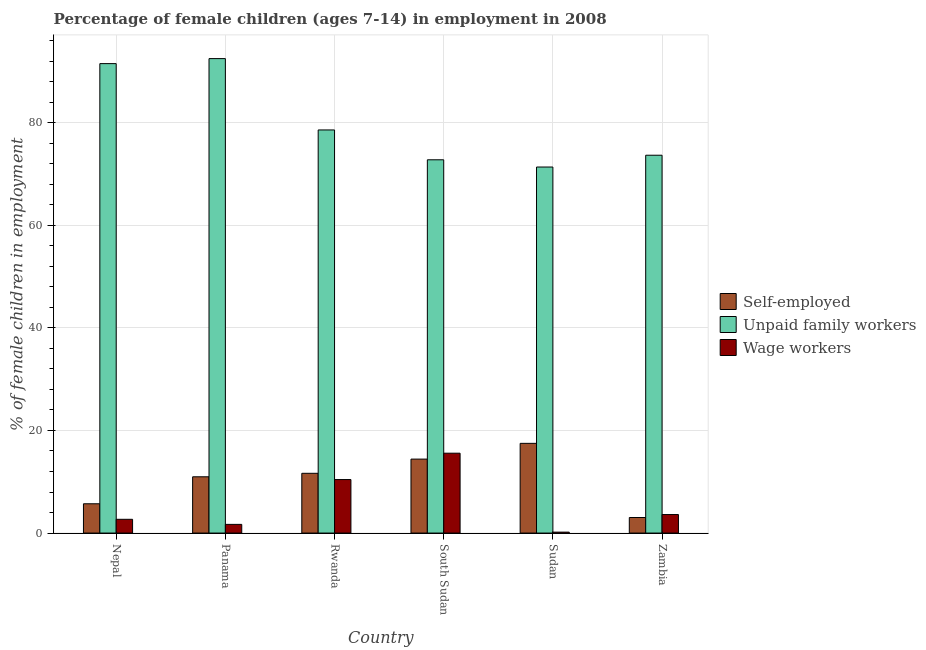How many different coloured bars are there?
Offer a terse response. 3. How many groups of bars are there?
Provide a short and direct response. 6. Are the number of bars per tick equal to the number of legend labels?
Offer a very short reply. Yes. How many bars are there on the 2nd tick from the right?
Give a very brief answer. 3. What is the label of the 3rd group of bars from the left?
Keep it short and to the point. Rwanda. In how many cases, is the number of bars for a given country not equal to the number of legend labels?
Keep it short and to the point. 0. What is the percentage of self employed children in Zambia?
Your answer should be very brief. 3.03. Across all countries, what is the maximum percentage of self employed children?
Offer a very short reply. 17.49. Across all countries, what is the minimum percentage of children employed as wage workers?
Make the answer very short. 0.18. In which country was the percentage of children employed as unpaid family workers maximum?
Provide a succinct answer. Panama. In which country was the percentage of self employed children minimum?
Make the answer very short. Zambia. What is the total percentage of self employed children in the graph?
Give a very brief answer. 63.27. What is the difference between the percentage of self employed children in Nepal and that in Rwanda?
Ensure brevity in your answer.  -5.94. What is the difference between the percentage of children employed as unpaid family workers in Sudan and the percentage of children employed as wage workers in South Sudan?
Keep it short and to the point. 55.8. What is the average percentage of children employed as unpaid family workers per country?
Offer a terse response. 80.08. What is the difference between the percentage of children employed as wage workers and percentage of children employed as unpaid family workers in Nepal?
Your answer should be very brief. -88.85. In how many countries, is the percentage of children employed as wage workers greater than 68 %?
Keep it short and to the point. 0. What is the ratio of the percentage of children employed as wage workers in Nepal to that in Zambia?
Your answer should be compact. 0.74. What is the difference between the highest and the second highest percentage of self employed children?
Your response must be concise. 3.07. What is the difference between the highest and the lowest percentage of children employed as wage workers?
Your answer should be very brief. 15.39. In how many countries, is the percentage of children employed as wage workers greater than the average percentage of children employed as wage workers taken over all countries?
Your answer should be compact. 2. Is the sum of the percentage of children employed as wage workers in South Sudan and Zambia greater than the maximum percentage of children employed as unpaid family workers across all countries?
Make the answer very short. No. What does the 2nd bar from the left in Panama represents?
Keep it short and to the point. Unpaid family workers. What does the 1st bar from the right in Nepal represents?
Your answer should be compact. Wage workers. How many bars are there?
Offer a terse response. 18. What is the difference between two consecutive major ticks on the Y-axis?
Provide a succinct answer. 20. Are the values on the major ticks of Y-axis written in scientific E-notation?
Offer a terse response. No. Does the graph contain any zero values?
Give a very brief answer. No. How many legend labels are there?
Offer a terse response. 3. What is the title of the graph?
Offer a very short reply. Percentage of female children (ages 7-14) in employment in 2008. What is the label or title of the Y-axis?
Your answer should be very brief. % of female children in employment. What is the % of female children in employment in Self-employed in Nepal?
Provide a short and direct response. 5.71. What is the % of female children in employment in Unpaid family workers in Nepal?
Your response must be concise. 91.53. What is the % of female children in employment of Wage workers in Nepal?
Your answer should be very brief. 2.68. What is the % of female children in employment in Self-employed in Panama?
Your answer should be compact. 10.97. What is the % of female children in employment in Unpaid family workers in Panama?
Provide a short and direct response. 92.51. What is the % of female children in employment of Wage workers in Panama?
Provide a short and direct response. 1.69. What is the % of female children in employment in Self-employed in Rwanda?
Provide a succinct answer. 11.65. What is the % of female children in employment in Unpaid family workers in Rwanda?
Keep it short and to the point. 78.6. What is the % of female children in employment in Wage workers in Rwanda?
Offer a very short reply. 10.43. What is the % of female children in employment of Self-employed in South Sudan?
Give a very brief answer. 14.42. What is the % of female children in employment in Unpaid family workers in South Sudan?
Keep it short and to the point. 72.78. What is the % of female children in employment of Wage workers in South Sudan?
Offer a very short reply. 15.57. What is the % of female children in employment in Self-employed in Sudan?
Give a very brief answer. 17.49. What is the % of female children in employment in Unpaid family workers in Sudan?
Your answer should be compact. 71.37. What is the % of female children in employment of Wage workers in Sudan?
Your answer should be very brief. 0.18. What is the % of female children in employment of Self-employed in Zambia?
Offer a very short reply. 3.03. What is the % of female children in employment of Unpaid family workers in Zambia?
Your response must be concise. 73.67. What is the % of female children in employment in Wage workers in Zambia?
Your response must be concise. 3.61. Across all countries, what is the maximum % of female children in employment in Self-employed?
Provide a short and direct response. 17.49. Across all countries, what is the maximum % of female children in employment in Unpaid family workers?
Offer a very short reply. 92.51. Across all countries, what is the maximum % of female children in employment in Wage workers?
Keep it short and to the point. 15.57. Across all countries, what is the minimum % of female children in employment in Self-employed?
Keep it short and to the point. 3.03. Across all countries, what is the minimum % of female children in employment of Unpaid family workers?
Keep it short and to the point. 71.37. Across all countries, what is the minimum % of female children in employment in Wage workers?
Give a very brief answer. 0.18. What is the total % of female children in employment in Self-employed in the graph?
Make the answer very short. 63.27. What is the total % of female children in employment of Unpaid family workers in the graph?
Make the answer very short. 480.46. What is the total % of female children in employment in Wage workers in the graph?
Offer a terse response. 34.16. What is the difference between the % of female children in employment in Self-employed in Nepal and that in Panama?
Provide a succinct answer. -5.26. What is the difference between the % of female children in employment of Unpaid family workers in Nepal and that in Panama?
Your answer should be compact. -0.98. What is the difference between the % of female children in employment of Wage workers in Nepal and that in Panama?
Your response must be concise. 0.99. What is the difference between the % of female children in employment of Self-employed in Nepal and that in Rwanda?
Offer a very short reply. -5.94. What is the difference between the % of female children in employment in Unpaid family workers in Nepal and that in Rwanda?
Provide a short and direct response. 12.93. What is the difference between the % of female children in employment in Wage workers in Nepal and that in Rwanda?
Your response must be concise. -7.75. What is the difference between the % of female children in employment of Self-employed in Nepal and that in South Sudan?
Your response must be concise. -8.71. What is the difference between the % of female children in employment in Unpaid family workers in Nepal and that in South Sudan?
Your answer should be very brief. 18.75. What is the difference between the % of female children in employment in Wage workers in Nepal and that in South Sudan?
Ensure brevity in your answer.  -12.89. What is the difference between the % of female children in employment of Self-employed in Nepal and that in Sudan?
Your response must be concise. -11.78. What is the difference between the % of female children in employment of Unpaid family workers in Nepal and that in Sudan?
Your response must be concise. 20.16. What is the difference between the % of female children in employment in Self-employed in Nepal and that in Zambia?
Your answer should be very brief. 2.68. What is the difference between the % of female children in employment of Unpaid family workers in Nepal and that in Zambia?
Offer a terse response. 17.86. What is the difference between the % of female children in employment in Wage workers in Nepal and that in Zambia?
Offer a very short reply. -0.93. What is the difference between the % of female children in employment of Self-employed in Panama and that in Rwanda?
Provide a short and direct response. -0.68. What is the difference between the % of female children in employment of Unpaid family workers in Panama and that in Rwanda?
Offer a very short reply. 13.91. What is the difference between the % of female children in employment in Wage workers in Panama and that in Rwanda?
Offer a terse response. -8.74. What is the difference between the % of female children in employment of Self-employed in Panama and that in South Sudan?
Keep it short and to the point. -3.45. What is the difference between the % of female children in employment in Unpaid family workers in Panama and that in South Sudan?
Give a very brief answer. 19.73. What is the difference between the % of female children in employment of Wage workers in Panama and that in South Sudan?
Offer a terse response. -13.88. What is the difference between the % of female children in employment of Self-employed in Panama and that in Sudan?
Your answer should be very brief. -6.52. What is the difference between the % of female children in employment in Unpaid family workers in Panama and that in Sudan?
Make the answer very short. 21.14. What is the difference between the % of female children in employment of Wage workers in Panama and that in Sudan?
Provide a short and direct response. 1.51. What is the difference between the % of female children in employment in Self-employed in Panama and that in Zambia?
Offer a terse response. 7.94. What is the difference between the % of female children in employment in Unpaid family workers in Panama and that in Zambia?
Your answer should be compact. 18.84. What is the difference between the % of female children in employment of Wage workers in Panama and that in Zambia?
Provide a short and direct response. -1.92. What is the difference between the % of female children in employment in Self-employed in Rwanda and that in South Sudan?
Your answer should be very brief. -2.77. What is the difference between the % of female children in employment of Unpaid family workers in Rwanda and that in South Sudan?
Your response must be concise. 5.82. What is the difference between the % of female children in employment of Wage workers in Rwanda and that in South Sudan?
Ensure brevity in your answer.  -5.14. What is the difference between the % of female children in employment in Self-employed in Rwanda and that in Sudan?
Keep it short and to the point. -5.84. What is the difference between the % of female children in employment in Unpaid family workers in Rwanda and that in Sudan?
Your answer should be very brief. 7.23. What is the difference between the % of female children in employment in Wage workers in Rwanda and that in Sudan?
Provide a short and direct response. 10.25. What is the difference between the % of female children in employment in Self-employed in Rwanda and that in Zambia?
Your answer should be compact. 8.62. What is the difference between the % of female children in employment in Unpaid family workers in Rwanda and that in Zambia?
Your answer should be compact. 4.93. What is the difference between the % of female children in employment of Wage workers in Rwanda and that in Zambia?
Your answer should be very brief. 6.82. What is the difference between the % of female children in employment of Self-employed in South Sudan and that in Sudan?
Provide a succinct answer. -3.07. What is the difference between the % of female children in employment of Unpaid family workers in South Sudan and that in Sudan?
Provide a succinct answer. 1.41. What is the difference between the % of female children in employment of Wage workers in South Sudan and that in Sudan?
Give a very brief answer. 15.39. What is the difference between the % of female children in employment of Self-employed in South Sudan and that in Zambia?
Provide a succinct answer. 11.39. What is the difference between the % of female children in employment in Unpaid family workers in South Sudan and that in Zambia?
Your response must be concise. -0.89. What is the difference between the % of female children in employment in Wage workers in South Sudan and that in Zambia?
Your answer should be compact. 11.96. What is the difference between the % of female children in employment in Self-employed in Sudan and that in Zambia?
Your answer should be very brief. 14.46. What is the difference between the % of female children in employment of Unpaid family workers in Sudan and that in Zambia?
Provide a short and direct response. -2.3. What is the difference between the % of female children in employment of Wage workers in Sudan and that in Zambia?
Your answer should be compact. -3.43. What is the difference between the % of female children in employment of Self-employed in Nepal and the % of female children in employment of Unpaid family workers in Panama?
Provide a succinct answer. -86.8. What is the difference between the % of female children in employment in Self-employed in Nepal and the % of female children in employment in Wage workers in Panama?
Offer a terse response. 4.02. What is the difference between the % of female children in employment of Unpaid family workers in Nepal and the % of female children in employment of Wage workers in Panama?
Keep it short and to the point. 89.84. What is the difference between the % of female children in employment of Self-employed in Nepal and the % of female children in employment of Unpaid family workers in Rwanda?
Provide a short and direct response. -72.89. What is the difference between the % of female children in employment in Self-employed in Nepal and the % of female children in employment in Wage workers in Rwanda?
Provide a short and direct response. -4.72. What is the difference between the % of female children in employment of Unpaid family workers in Nepal and the % of female children in employment of Wage workers in Rwanda?
Keep it short and to the point. 81.1. What is the difference between the % of female children in employment in Self-employed in Nepal and the % of female children in employment in Unpaid family workers in South Sudan?
Your answer should be compact. -67.07. What is the difference between the % of female children in employment of Self-employed in Nepal and the % of female children in employment of Wage workers in South Sudan?
Make the answer very short. -9.86. What is the difference between the % of female children in employment in Unpaid family workers in Nepal and the % of female children in employment in Wage workers in South Sudan?
Your answer should be compact. 75.96. What is the difference between the % of female children in employment of Self-employed in Nepal and the % of female children in employment of Unpaid family workers in Sudan?
Provide a succinct answer. -65.66. What is the difference between the % of female children in employment of Self-employed in Nepal and the % of female children in employment of Wage workers in Sudan?
Ensure brevity in your answer.  5.53. What is the difference between the % of female children in employment of Unpaid family workers in Nepal and the % of female children in employment of Wage workers in Sudan?
Offer a terse response. 91.35. What is the difference between the % of female children in employment in Self-employed in Nepal and the % of female children in employment in Unpaid family workers in Zambia?
Your response must be concise. -67.96. What is the difference between the % of female children in employment in Unpaid family workers in Nepal and the % of female children in employment in Wage workers in Zambia?
Provide a succinct answer. 87.92. What is the difference between the % of female children in employment in Self-employed in Panama and the % of female children in employment in Unpaid family workers in Rwanda?
Your answer should be compact. -67.63. What is the difference between the % of female children in employment in Self-employed in Panama and the % of female children in employment in Wage workers in Rwanda?
Make the answer very short. 0.54. What is the difference between the % of female children in employment in Unpaid family workers in Panama and the % of female children in employment in Wage workers in Rwanda?
Make the answer very short. 82.08. What is the difference between the % of female children in employment of Self-employed in Panama and the % of female children in employment of Unpaid family workers in South Sudan?
Provide a short and direct response. -61.81. What is the difference between the % of female children in employment in Unpaid family workers in Panama and the % of female children in employment in Wage workers in South Sudan?
Your answer should be compact. 76.94. What is the difference between the % of female children in employment in Self-employed in Panama and the % of female children in employment in Unpaid family workers in Sudan?
Your response must be concise. -60.4. What is the difference between the % of female children in employment in Self-employed in Panama and the % of female children in employment in Wage workers in Sudan?
Ensure brevity in your answer.  10.79. What is the difference between the % of female children in employment in Unpaid family workers in Panama and the % of female children in employment in Wage workers in Sudan?
Give a very brief answer. 92.33. What is the difference between the % of female children in employment in Self-employed in Panama and the % of female children in employment in Unpaid family workers in Zambia?
Your response must be concise. -62.7. What is the difference between the % of female children in employment of Self-employed in Panama and the % of female children in employment of Wage workers in Zambia?
Give a very brief answer. 7.36. What is the difference between the % of female children in employment of Unpaid family workers in Panama and the % of female children in employment of Wage workers in Zambia?
Provide a succinct answer. 88.9. What is the difference between the % of female children in employment in Self-employed in Rwanda and the % of female children in employment in Unpaid family workers in South Sudan?
Your response must be concise. -61.13. What is the difference between the % of female children in employment in Self-employed in Rwanda and the % of female children in employment in Wage workers in South Sudan?
Keep it short and to the point. -3.92. What is the difference between the % of female children in employment in Unpaid family workers in Rwanda and the % of female children in employment in Wage workers in South Sudan?
Provide a short and direct response. 63.03. What is the difference between the % of female children in employment in Self-employed in Rwanda and the % of female children in employment in Unpaid family workers in Sudan?
Offer a very short reply. -59.72. What is the difference between the % of female children in employment of Self-employed in Rwanda and the % of female children in employment of Wage workers in Sudan?
Give a very brief answer. 11.47. What is the difference between the % of female children in employment in Unpaid family workers in Rwanda and the % of female children in employment in Wage workers in Sudan?
Keep it short and to the point. 78.42. What is the difference between the % of female children in employment in Self-employed in Rwanda and the % of female children in employment in Unpaid family workers in Zambia?
Provide a short and direct response. -62.02. What is the difference between the % of female children in employment in Self-employed in Rwanda and the % of female children in employment in Wage workers in Zambia?
Your answer should be compact. 8.04. What is the difference between the % of female children in employment in Unpaid family workers in Rwanda and the % of female children in employment in Wage workers in Zambia?
Make the answer very short. 74.99. What is the difference between the % of female children in employment of Self-employed in South Sudan and the % of female children in employment of Unpaid family workers in Sudan?
Provide a short and direct response. -56.95. What is the difference between the % of female children in employment in Self-employed in South Sudan and the % of female children in employment in Wage workers in Sudan?
Your response must be concise. 14.24. What is the difference between the % of female children in employment in Unpaid family workers in South Sudan and the % of female children in employment in Wage workers in Sudan?
Your answer should be compact. 72.6. What is the difference between the % of female children in employment of Self-employed in South Sudan and the % of female children in employment of Unpaid family workers in Zambia?
Keep it short and to the point. -59.25. What is the difference between the % of female children in employment in Self-employed in South Sudan and the % of female children in employment in Wage workers in Zambia?
Provide a short and direct response. 10.81. What is the difference between the % of female children in employment in Unpaid family workers in South Sudan and the % of female children in employment in Wage workers in Zambia?
Your response must be concise. 69.17. What is the difference between the % of female children in employment in Self-employed in Sudan and the % of female children in employment in Unpaid family workers in Zambia?
Offer a terse response. -56.18. What is the difference between the % of female children in employment of Self-employed in Sudan and the % of female children in employment of Wage workers in Zambia?
Keep it short and to the point. 13.88. What is the difference between the % of female children in employment of Unpaid family workers in Sudan and the % of female children in employment of Wage workers in Zambia?
Provide a succinct answer. 67.76. What is the average % of female children in employment of Self-employed per country?
Offer a terse response. 10.54. What is the average % of female children in employment in Unpaid family workers per country?
Keep it short and to the point. 80.08. What is the average % of female children in employment of Wage workers per country?
Offer a terse response. 5.69. What is the difference between the % of female children in employment of Self-employed and % of female children in employment of Unpaid family workers in Nepal?
Your answer should be very brief. -85.82. What is the difference between the % of female children in employment in Self-employed and % of female children in employment in Wage workers in Nepal?
Provide a succinct answer. 3.03. What is the difference between the % of female children in employment of Unpaid family workers and % of female children in employment of Wage workers in Nepal?
Provide a succinct answer. 88.85. What is the difference between the % of female children in employment in Self-employed and % of female children in employment in Unpaid family workers in Panama?
Ensure brevity in your answer.  -81.54. What is the difference between the % of female children in employment of Self-employed and % of female children in employment of Wage workers in Panama?
Your response must be concise. 9.28. What is the difference between the % of female children in employment of Unpaid family workers and % of female children in employment of Wage workers in Panama?
Provide a short and direct response. 90.82. What is the difference between the % of female children in employment in Self-employed and % of female children in employment in Unpaid family workers in Rwanda?
Offer a very short reply. -66.95. What is the difference between the % of female children in employment of Self-employed and % of female children in employment of Wage workers in Rwanda?
Your answer should be very brief. 1.22. What is the difference between the % of female children in employment of Unpaid family workers and % of female children in employment of Wage workers in Rwanda?
Your answer should be very brief. 68.17. What is the difference between the % of female children in employment in Self-employed and % of female children in employment in Unpaid family workers in South Sudan?
Keep it short and to the point. -58.36. What is the difference between the % of female children in employment of Self-employed and % of female children in employment of Wage workers in South Sudan?
Give a very brief answer. -1.15. What is the difference between the % of female children in employment in Unpaid family workers and % of female children in employment in Wage workers in South Sudan?
Your answer should be compact. 57.21. What is the difference between the % of female children in employment of Self-employed and % of female children in employment of Unpaid family workers in Sudan?
Offer a terse response. -53.88. What is the difference between the % of female children in employment of Self-employed and % of female children in employment of Wage workers in Sudan?
Ensure brevity in your answer.  17.31. What is the difference between the % of female children in employment in Unpaid family workers and % of female children in employment in Wage workers in Sudan?
Ensure brevity in your answer.  71.19. What is the difference between the % of female children in employment of Self-employed and % of female children in employment of Unpaid family workers in Zambia?
Keep it short and to the point. -70.64. What is the difference between the % of female children in employment of Self-employed and % of female children in employment of Wage workers in Zambia?
Give a very brief answer. -0.58. What is the difference between the % of female children in employment in Unpaid family workers and % of female children in employment in Wage workers in Zambia?
Your answer should be very brief. 70.06. What is the ratio of the % of female children in employment of Self-employed in Nepal to that in Panama?
Your response must be concise. 0.52. What is the ratio of the % of female children in employment in Unpaid family workers in Nepal to that in Panama?
Give a very brief answer. 0.99. What is the ratio of the % of female children in employment of Wage workers in Nepal to that in Panama?
Your answer should be compact. 1.59. What is the ratio of the % of female children in employment in Self-employed in Nepal to that in Rwanda?
Offer a terse response. 0.49. What is the ratio of the % of female children in employment of Unpaid family workers in Nepal to that in Rwanda?
Make the answer very short. 1.16. What is the ratio of the % of female children in employment in Wage workers in Nepal to that in Rwanda?
Offer a terse response. 0.26. What is the ratio of the % of female children in employment of Self-employed in Nepal to that in South Sudan?
Give a very brief answer. 0.4. What is the ratio of the % of female children in employment in Unpaid family workers in Nepal to that in South Sudan?
Make the answer very short. 1.26. What is the ratio of the % of female children in employment of Wage workers in Nepal to that in South Sudan?
Ensure brevity in your answer.  0.17. What is the ratio of the % of female children in employment in Self-employed in Nepal to that in Sudan?
Provide a short and direct response. 0.33. What is the ratio of the % of female children in employment in Unpaid family workers in Nepal to that in Sudan?
Offer a very short reply. 1.28. What is the ratio of the % of female children in employment in Wage workers in Nepal to that in Sudan?
Your answer should be compact. 14.89. What is the ratio of the % of female children in employment in Self-employed in Nepal to that in Zambia?
Ensure brevity in your answer.  1.88. What is the ratio of the % of female children in employment of Unpaid family workers in Nepal to that in Zambia?
Make the answer very short. 1.24. What is the ratio of the % of female children in employment in Wage workers in Nepal to that in Zambia?
Your response must be concise. 0.74. What is the ratio of the % of female children in employment in Self-employed in Panama to that in Rwanda?
Ensure brevity in your answer.  0.94. What is the ratio of the % of female children in employment in Unpaid family workers in Panama to that in Rwanda?
Provide a succinct answer. 1.18. What is the ratio of the % of female children in employment in Wage workers in Panama to that in Rwanda?
Offer a terse response. 0.16. What is the ratio of the % of female children in employment of Self-employed in Panama to that in South Sudan?
Your answer should be very brief. 0.76. What is the ratio of the % of female children in employment in Unpaid family workers in Panama to that in South Sudan?
Offer a very short reply. 1.27. What is the ratio of the % of female children in employment in Wage workers in Panama to that in South Sudan?
Keep it short and to the point. 0.11. What is the ratio of the % of female children in employment in Self-employed in Panama to that in Sudan?
Keep it short and to the point. 0.63. What is the ratio of the % of female children in employment of Unpaid family workers in Panama to that in Sudan?
Keep it short and to the point. 1.3. What is the ratio of the % of female children in employment of Wage workers in Panama to that in Sudan?
Give a very brief answer. 9.39. What is the ratio of the % of female children in employment in Self-employed in Panama to that in Zambia?
Your response must be concise. 3.62. What is the ratio of the % of female children in employment in Unpaid family workers in Panama to that in Zambia?
Offer a terse response. 1.26. What is the ratio of the % of female children in employment of Wage workers in Panama to that in Zambia?
Your answer should be compact. 0.47. What is the ratio of the % of female children in employment in Self-employed in Rwanda to that in South Sudan?
Your answer should be very brief. 0.81. What is the ratio of the % of female children in employment in Unpaid family workers in Rwanda to that in South Sudan?
Offer a terse response. 1.08. What is the ratio of the % of female children in employment in Wage workers in Rwanda to that in South Sudan?
Offer a very short reply. 0.67. What is the ratio of the % of female children in employment of Self-employed in Rwanda to that in Sudan?
Your answer should be very brief. 0.67. What is the ratio of the % of female children in employment of Unpaid family workers in Rwanda to that in Sudan?
Ensure brevity in your answer.  1.1. What is the ratio of the % of female children in employment of Wage workers in Rwanda to that in Sudan?
Give a very brief answer. 57.94. What is the ratio of the % of female children in employment of Self-employed in Rwanda to that in Zambia?
Your answer should be very brief. 3.84. What is the ratio of the % of female children in employment of Unpaid family workers in Rwanda to that in Zambia?
Your response must be concise. 1.07. What is the ratio of the % of female children in employment in Wage workers in Rwanda to that in Zambia?
Keep it short and to the point. 2.89. What is the ratio of the % of female children in employment in Self-employed in South Sudan to that in Sudan?
Your answer should be compact. 0.82. What is the ratio of the % of female children in employment of Unpaid family workers in South Sudan to that in Sudan?
Offer a very short reply. 1.02. What is the ratio of the % of female children in employment in Wage workers in South Sudan to that in Sudan?
Give a very brief answer. 86.5. What is the ratio of the % of female children in employment in Self-employed in South Sudan to that in Zambia?
Offer a very short reply. 4.76. What is the ratio of the % of female children in employment of Unpaid family workers in South Sudan to that in Zambia?
Your answer should be compact. 0.99. What is the ratio of the % of female children in employment in Wage workers in South Sudan to that in Zambia?
Give a very brief answer. 4.31. What is the ratio of the % of female children in employment in Self-employed in Sudan to that in Zambia?
Offer a terse response. 5.77. What is the ratio of the % of female children in employment in Unpaid family workers in Sudan to that in Zambia?
Offer a very short reply. 0.97. What is the ratio of the % of female children in employment of Wage workers in Sudan to that in Zambia?
Keep it short and to the point. 0.05. What is the difference between the highest and the second highest % of female children in employment in Self-employed?
Your response must be concise. 3.07. What is the difference between the highest and the second highest % of female children in employment of Unpaid family workers?
Your answer should be very brief. 0.98. What is the difference between the highest and the second highest % of female children in employment of Wage workers?
Offer a terse response. 5.14. What is the difference between the highest and the lowest % of female children in employment of Self-employed?
Your response must be concise. 14.46. What is the difference between the highest and the lowest % of female children in employment of Unpaid family workers?
Provide a succinct answer. 21.14. What is the difference between the highest and the lowest % of female children in employment in Wage workers?
Offer a terse response. 15.39. 